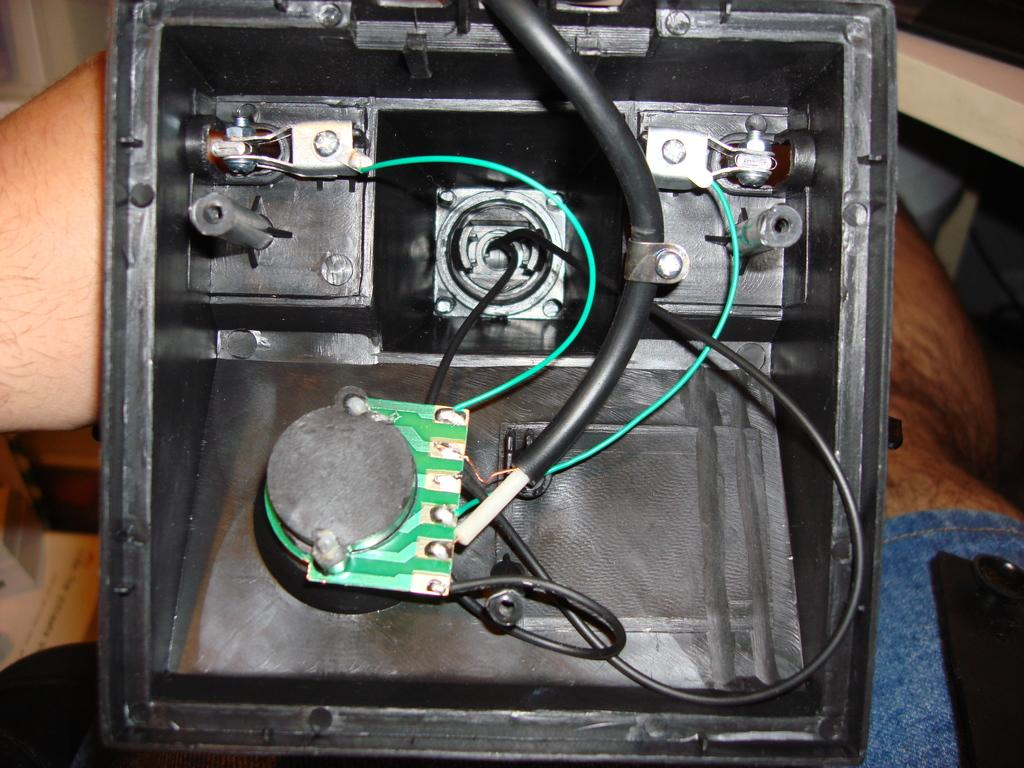What is the main object in the center of the image? There is an object with wires in the center of the image. Can you describe any other elements in the image? A person's leg is visible at the bottom of the image. What type of vegetable is being cooked in the soup in the image? There is no soup or vegetable present in the image. How many legs are visible in the image? Only one leg is visible in the image. 